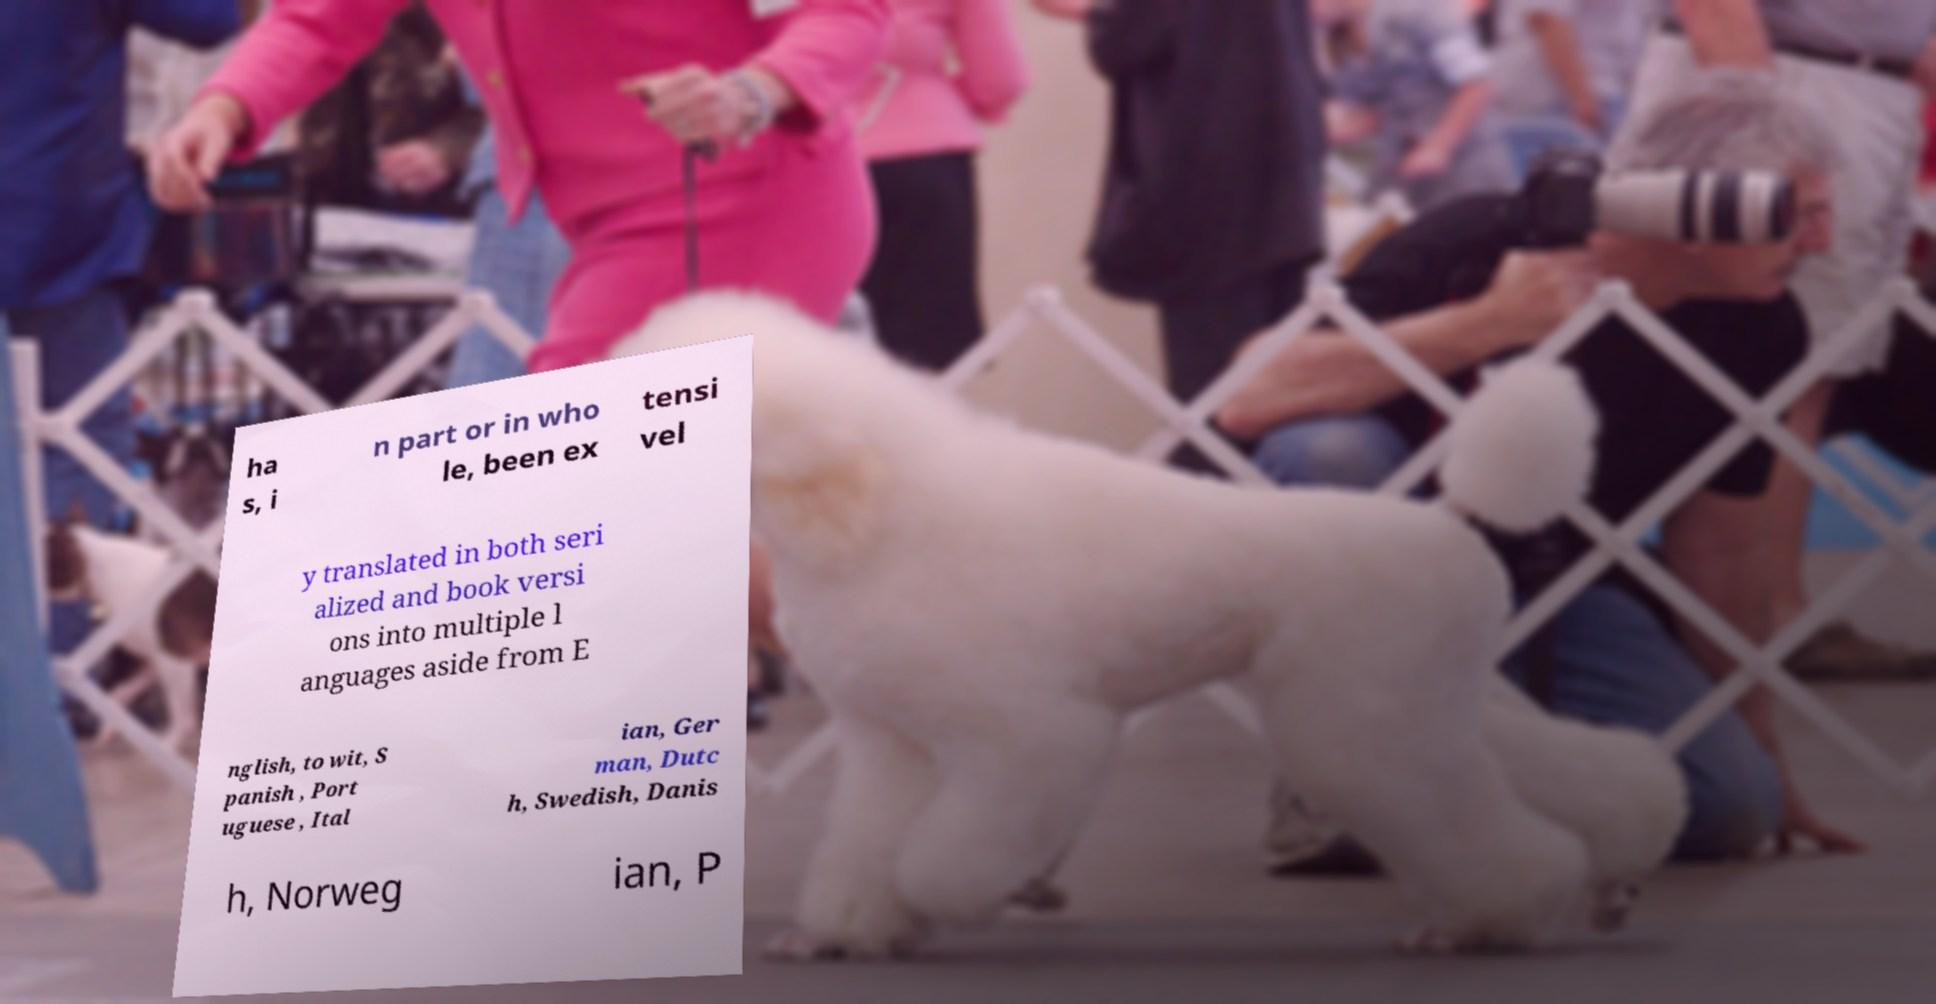Could you assist in decoding the text presented in this image and type it out clearly? ha s, i n part or in who le, been ex tensi vel y translated in both seri alized and book versi ons into multiple l anguages aside from E nglish, to wit, S panish , Port uguese , Ital ian, Ger man, Dutc h, Swedish, Danis h, Norweg ian, P 